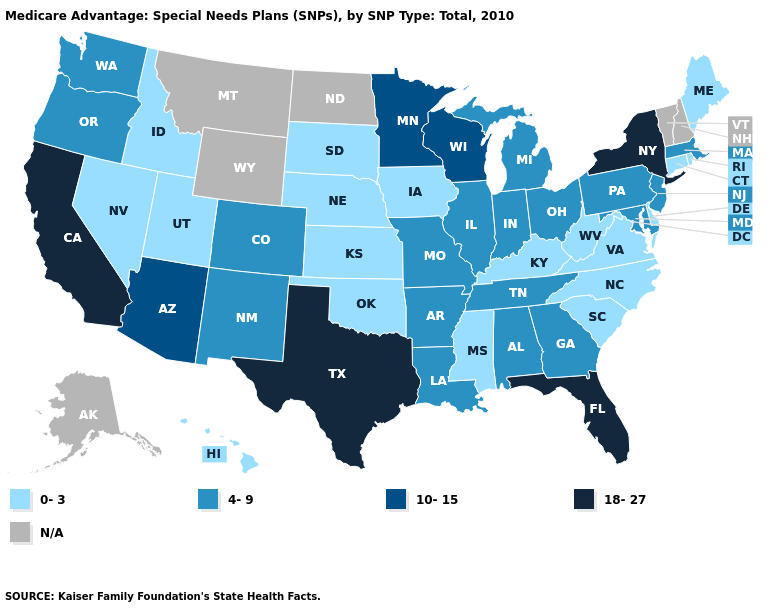What is the value of Texas?
Keep it brief. 18-27. Among the states that border Vermont , does Massachusetts have the lowest value?
Keep it brief. Yes. Name the states that have a value in the range N/A?
Short answer required. Alaska, Montana, North Dakota, New Hampshire, Vermont, Wyoming. What is the highest value in the USA?
Short answer required. 18-27. Does California have the highest value in the USA?
Short answer required. Yes. Does California have the highest value in the USA?
Be succinct. Yes. What is the value of Minnesota?
Be succinct. 10-15. Name the states that have a value in the range 10-15?
Answer briefly. Arizona, Minnesota, Wisconsin. Among the states that border Illinois , which have the lowest value?
Write a very short answer. Iowa, Kentucky. Name the states that have a value in the range 18-27?
Write a very short answer. California, Florida, New York, Texas. What is the lowest value in states that border Washington?
Be succinct. 0-3. What is the value of Louisiana?
Quick response, please. 4-9. Is the legend a continuous bar?
Short answer required. No. Name the states that have a value in the range 18-27?
Quick response, please. California, Florida, New York, Texas. Name the states that have a value in the range N/A?
Keep it brief. Alaska, Montana, North Dakota, New Hampshire, Vermont, Wyoming. 